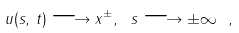<formula> <loc_0><loc_0><loc_500><loc_500>u ( s , \, t ) \longrightarrow x ^ { \pm } , \ s \longrightarrow \pm \infty \ ,</formula> 